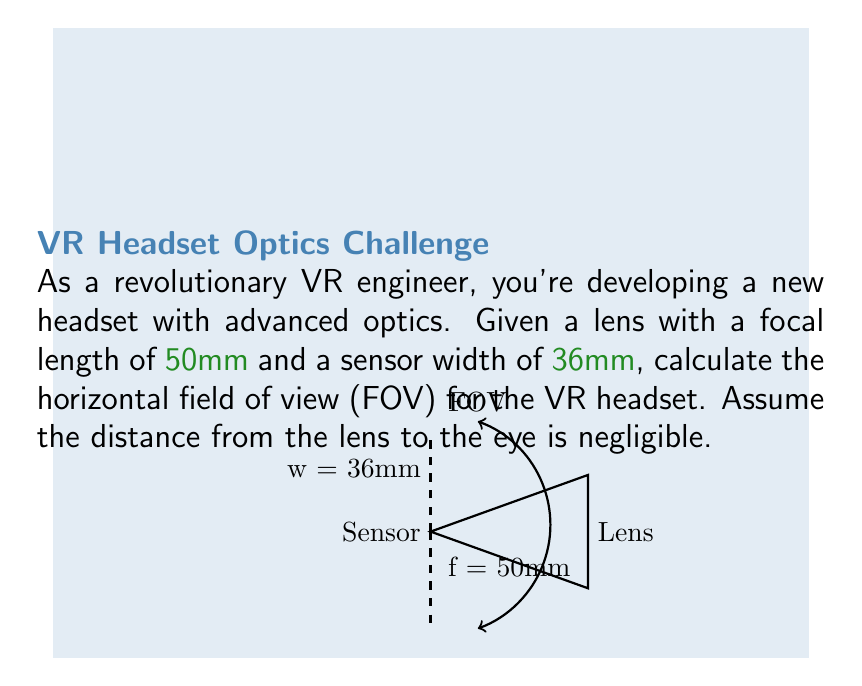Help me with this question. To calculate the horizontal field of view (FOV) for the VR headset, we'll use the following steps:

1) The FOV is determined by the angle formed between the edges of the sensor when viewed through the lens. We can calculate this using the arctangent function.

2) In this case, we need to find the angle between the optical axis and the line from the lens to the edge of the sensor. This forms a right triangle.

3) The adjacent side of this triangle is the focal length (f) = 50mm.
   The opposite side is half the sensor width (w/2) = 36mm / 2 = 18mm.

4) We can calculate the angle θ using the arctangent function:

   $$θ = \arctan(\frac{w/2}{f})$$

5) Substituting our values:

   $$θ = \arctan(\frac{18}{50})$$

6) Calculate:
   
   $$θ ≈ 19.80°$$

7) This angle θ represents half of our total FOV. To get the full FOV, we multiply by 2:

   $$FOV = 2θ ≈ 2 * 19.80° = 39.60°$$

Therefore, the horizontal field of view for the VR headset is approximately 39.60°.
Answer: $39.60°$ 